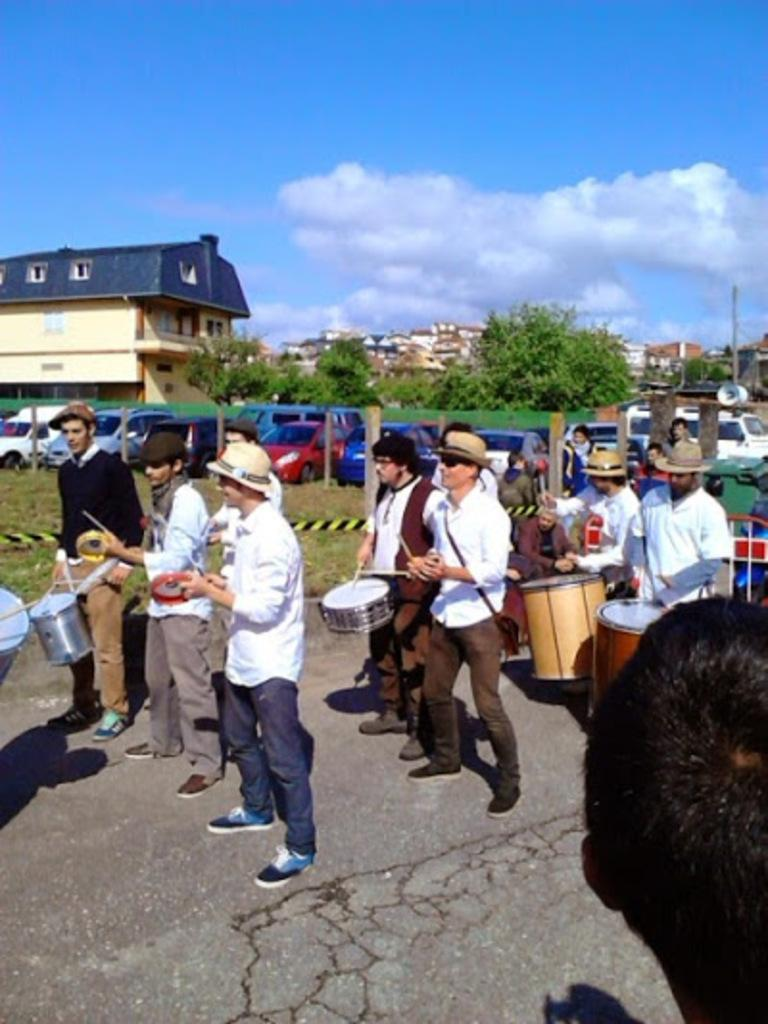What is happening in the image involving the people? Most of the people are holding instruments, which suggests they are participating in a musical performance or event. What can be seen in the background of the image? There are cars, buildings, trees, and the sky visible in the background of the image. Can you describe the setting of the image? The image appears to be set in an urban environment, with buildings and cars in the background. What type of liquid is being poured from a minute card in the image? There is no liquid or card present in the image; it features people holding instruments and an urban background. 